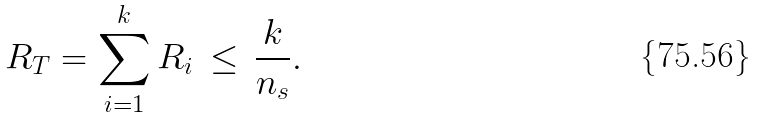<formula> <loc_0><loc_0><loc_500><loc_500>R _ { T } = \sum _ { i = 1 } ^ { k } R _ { i } \, \leq \, \frac { k } { n _ { s } } .</formula> 